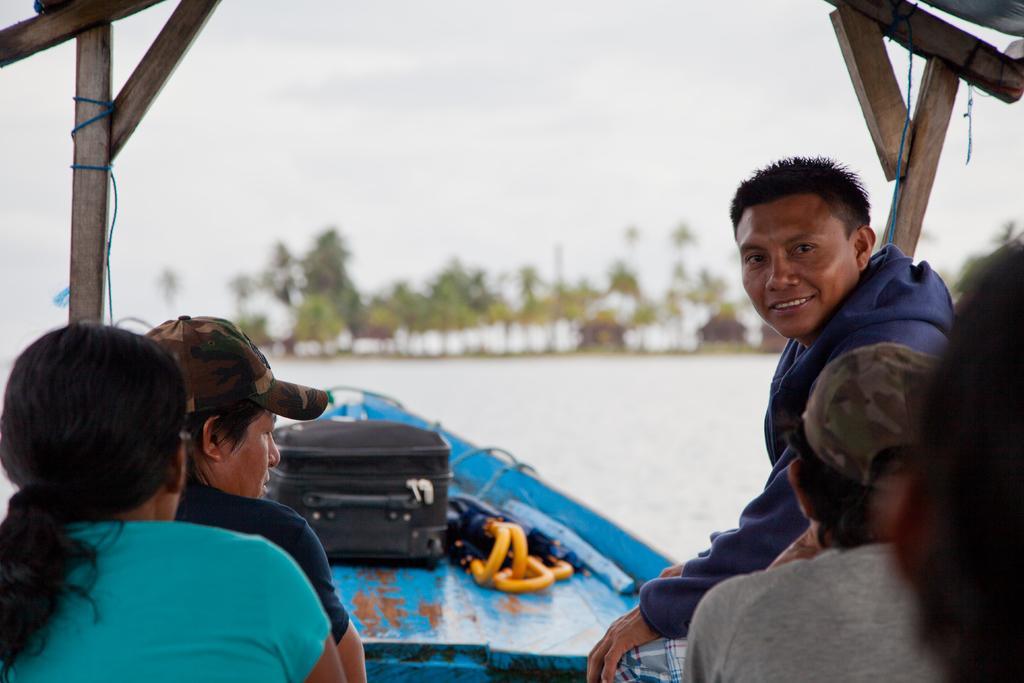Could you give a brief overview of what you see in this image? In this image I can see people sitting on a boat. In the background there are some trees. At the top I can see sky. 